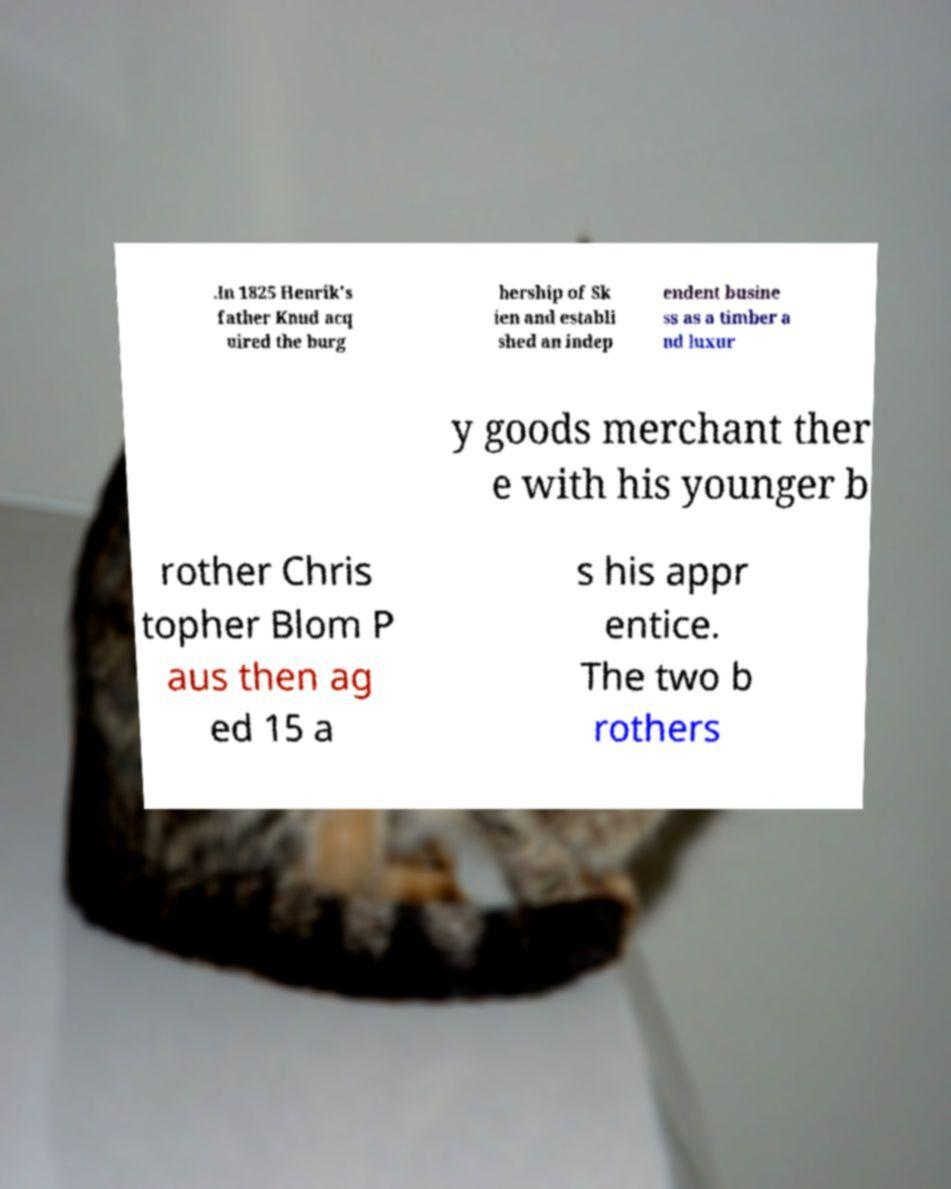For documentation purposes, I need the text within this image transcribed. Could you provide that? .In 1825 Henrik's father Knud acq uired the burg hership of Sk ien and establi shed an indep endent busine ss as a timber a nd luxur y goods merchant ther e with his younger b rother Chris topher Blom P aus then ag ed 15 a s his appr entice. The two b rothers 